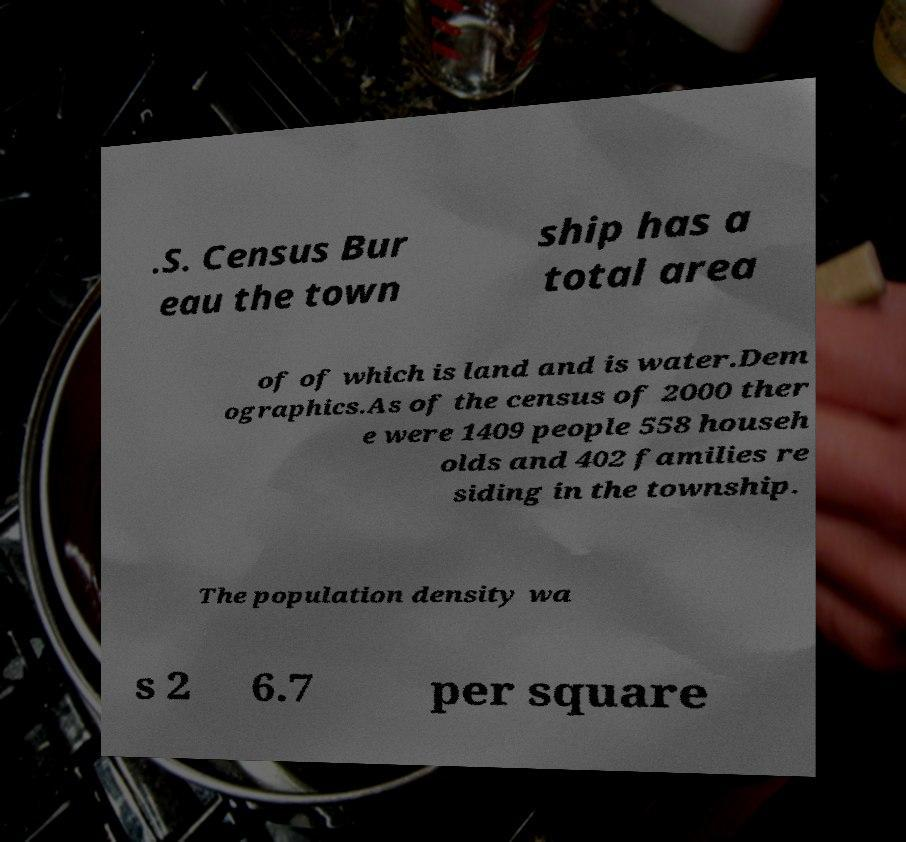I need the written content from this picture converted into text. Can you do that? .S. Census Bur eau the town ship has a total area of of which is land and is water.Dem ographics.As of the census of 2000 ther e were 1409 people 558 househ olds and 402 families re siding in the township. The population density wa s 2 6.7 per square 